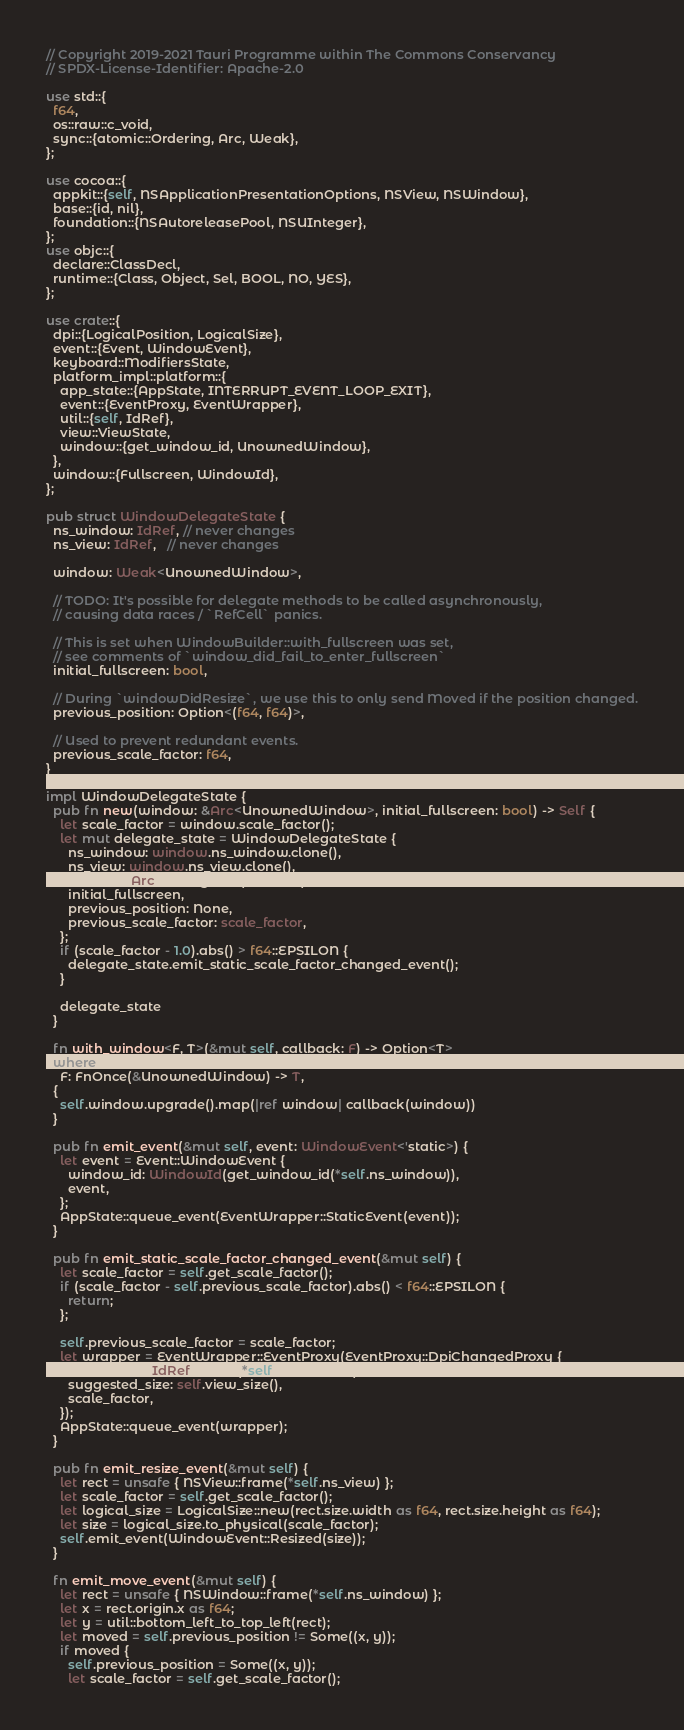Convert code to text. <code><loc_0><loc_0><loc_500><loc_500><_Rust_>// Copyright 2019-2021 Tauri Programme within The Commons Conservancy
// SPDX-License-Identifier: Apache-2.0

use std::{
  f64,
  os::raw::c_void,
  sync::{atomic::Ordering, Arc, Weak},
};

use cocoa::{
  appkit::{self, NSApplicationPresentationOptions, NSView, NSWindow},
  base::{id, nil},
  foundation::{NSAutoreleasePool, NSUInteger},
};
use objc::{
  declare::ClassDecl,
  runtime::{Class, Object, Sel, BOOL, NO, YES},
};

use crate::{
  dpi::{LogicalPosition, LogicalSize},
  event::{Event, WindowEvent},
  keyboard::ModifiersState,
  platform_impl::platform::{
    app_state::{AppState, INTERRUPT_EVENT_LOOP_EXIT},
    event::{EventProxy, EventWrapper},
    util::{self, IdRef},
    view::ViewState,
    window::{get_window_id, UnownedWindow},
  },
  window::{Fullscreen, WindowId},
};

pub struct WindowDelegateState {
  ns_window: IdRef, // never changes
  ns_view: IdRef,   // never changes

  window: Weak<UnownedWindow>,

  // TODO: It's possible for delegate methods to be called asynchronously,
  // causing data races / `RefCell` panics.

  // This is set when WindowBuilder::with_fullscreen was set,
  // see comments of `window_did_fail_to_enter_fullscreen`
  initial_fullscreen: bool,

  // During `windowDidResize`, we use this to only send Moved if the position changed.
  previous_position: Option<(f64, f64)>,

  // Used to prevent redundant events.
  previous_scale_factor: f64,
}

impl WindowDelegateState {
  pub fn new(window: &Arc<UnownedWindow>, initial_fullscreen: bool) -> Self {
    let scale_factor = window.scale_factor();
    let mut delegate_state = WindowDelegateState {
      ns_window: window.ns_window.clone(),
      ns_view: window.ns_view.clone(),
      window: Arc::downgrade(window),
      initial_fullscreen,
      previous_position: None,
      previous_scale_factor: scale_factor,
    };
    if (scale_factor - 1.0).abs() > f64::EPSILON {
      delegate_state.emit_static_scale_factor_changed_event();
    }

    delegate_state
  }

  fn with_window<F, T>(&mut self, callback: F) -> Option<T>
  where
    F: FnOnce(&UnownedWindow) -> T,
  {
    self.window.upgrade().map(|ref window| callback(window))
  }

  pub fn emit_event(&mut self, event: WindowEvent<'static>) {
    let event = Event::WindowEvent {
      window_id: WindowId(get_window_id(*self.ns_window)),
      event,
    };
    AppState::queue_event(EventWrapper::StaticEvent(event));
  }

  pub fn emit_static_scale_factor_changed_event(&mut self) {
    let scale_factor = self.get_scale_factor();
    if (scale_factor - self.previous_scale_factor).abs() < f64::EPSILON {
      return;
    };

    self.previous_scale_factor = scale_factor;
    let wrapper = EventWrapper::EventProxy(EventProxy::DpiChangedProxy {
      ns_window: IdRef::retain(*self.ns_window),
      suggested_size: self.view_size(),
      scale_factor,
    });
    AppState::queue_event(wrapper);
  }

  pub fn emit_resize_event(&mut self) {
    let rect = unsafe { NSView::frame(*self.ns_view) };
    let scale_factor = self.get_scale_factor();
    let logical_size = LogicalSize::new(rect.size.width as f64, rect.size.height as f64);
    let size = logical_size.to_physical(scale_factor);
    self.emit_event(WindowEvent::Resized(size));
  }

  fn emit_move_event(&mut self) {
    let rect = unsafe { NSWindow::frame(*self.ns_window) };
    let x = rect.origin.x as f64;
    let y = util::bottom_left_to_top_left(rect);
    let moved = self.previous_position != Some((x, y));
    if moved {
      self.previous_position = Some((x, y));
      let scale_factor = self.get_scale_factor();</code> 